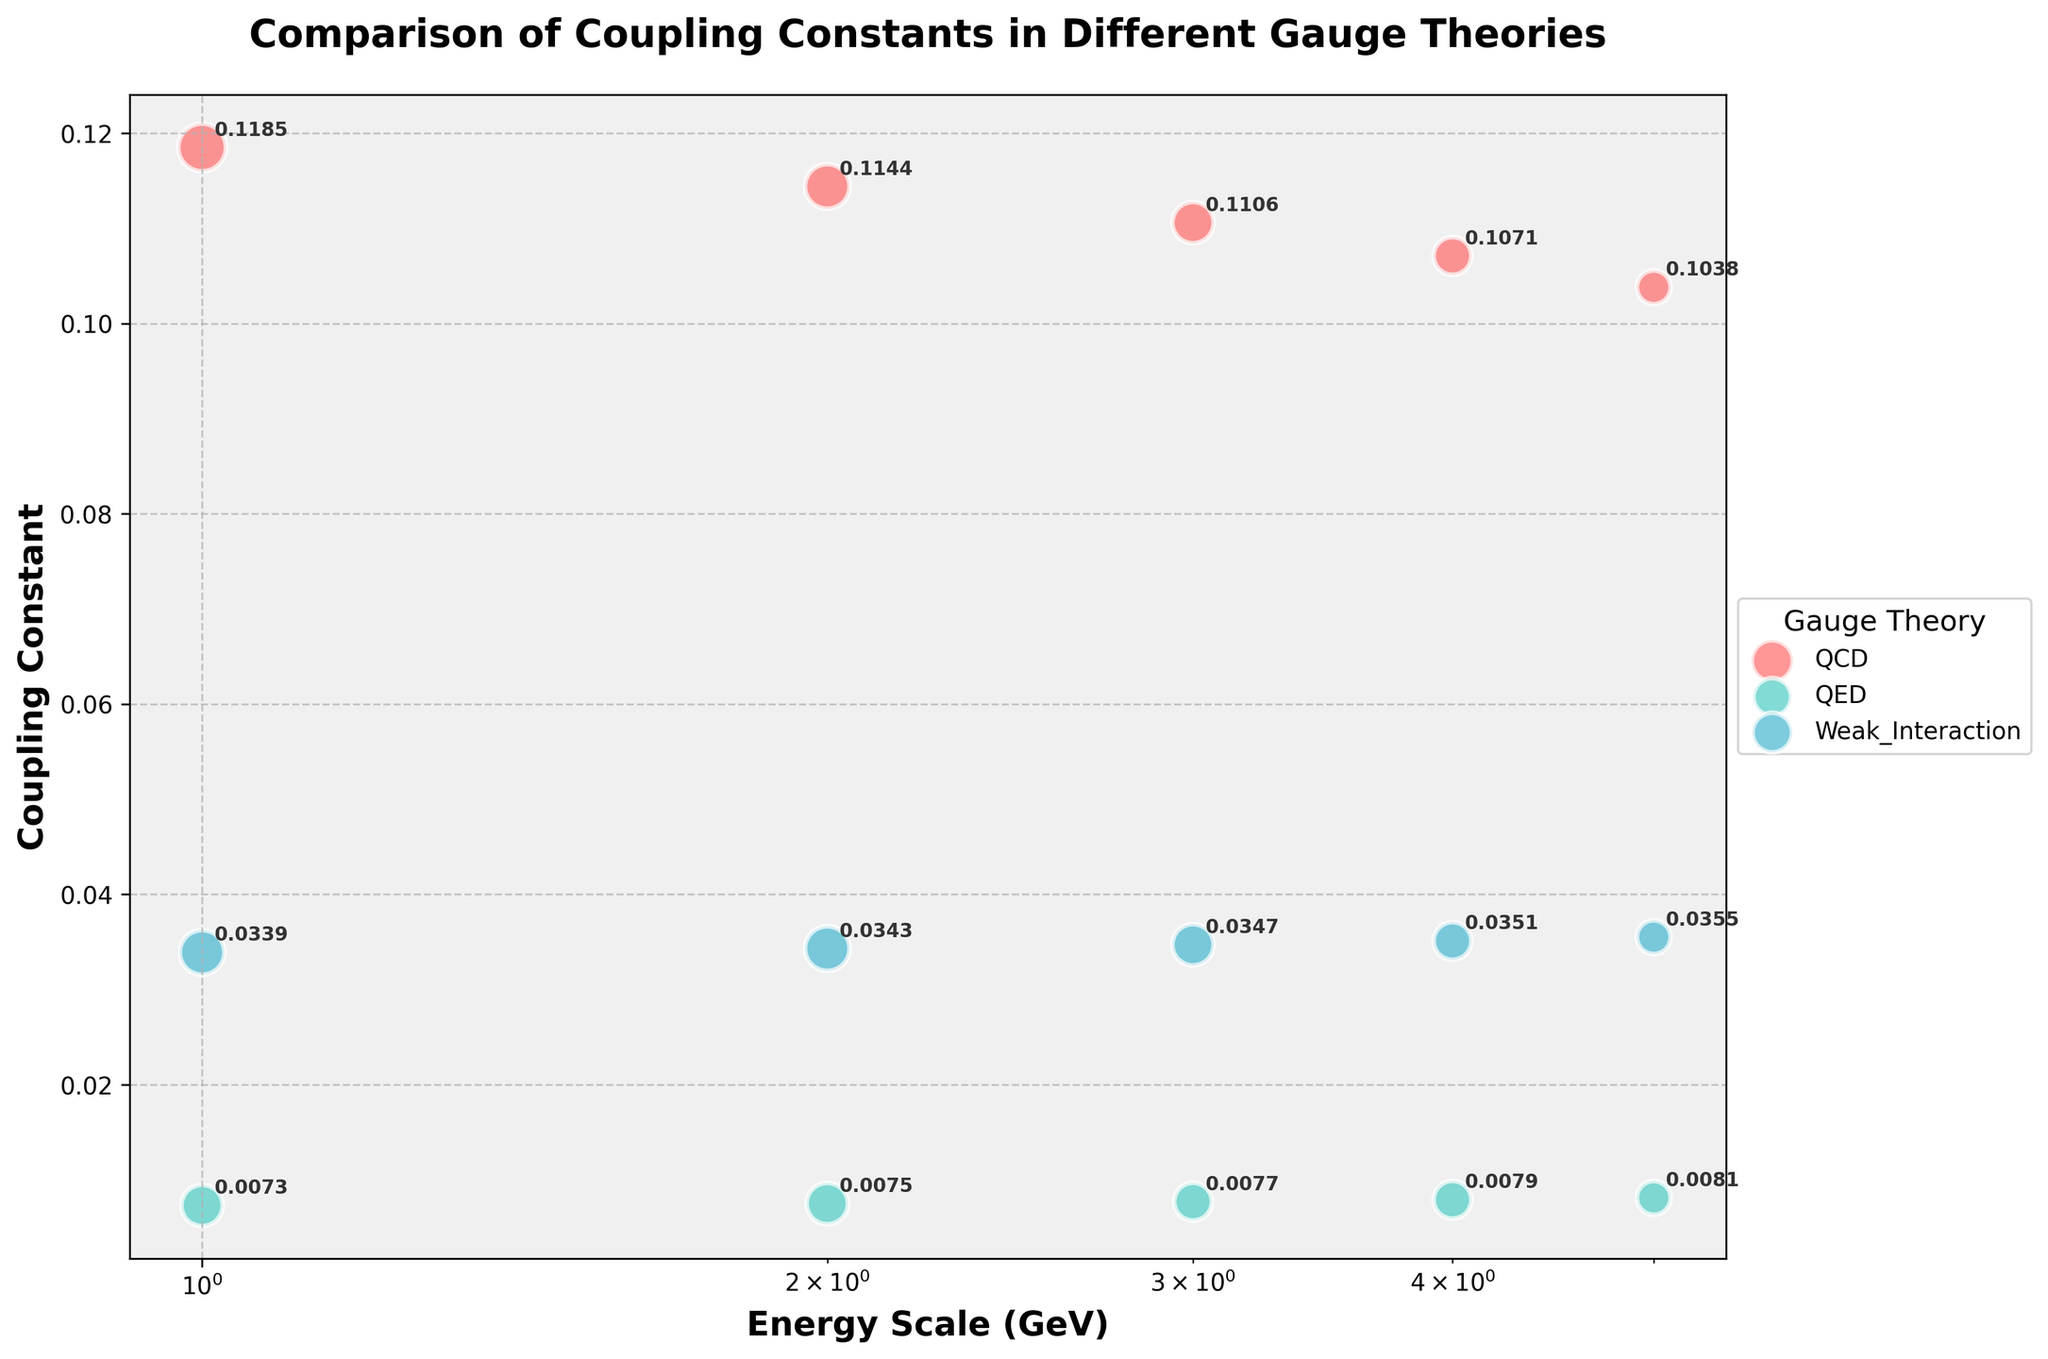What does the figure's title convey? The title of the figure is "Comparison of Coupling Constants in Different Gauge Theories". This indicates that the figure is comparing the values of coupling constants across various gauge theories over different energy scales.
Answer: Comparison of Coupling Constants in Different Gauge Theories How many different gauge theories are represented, and which ones are they? The figure shows three different gauge theories represented by different colors. These are QCD (Quantum Chromodynamics), QED (Quantum Electrodynamics), and Weak Interaction.
Answer: QCD, QED, Weak Interaction What pattern do you observe in the coupling constants of QCD as the energy scale increases? As the energy scale increases, the coupling constant of QCD decreases. This can be observed by looking at the downward trend in the orange bubble's positions on the y-axis as the x-axis values increase.
Answer: Decreases How does the theoretical importance vary between QCD and QED at an energy scale of 10 GeV? At an energy scale of 10 GeV, the theoretical importance for QCD is 8 and for QED is 6. This means that QCD has a higher theoretical importance than QED at this energy scale.
Answer: QCD: 8, QED: 6 Which gauge theory exhibits the smallest change in its coupling constant across the entire energy scale range? The QED gauge theory exhibits the smallest change in its coupling constant across the entire energy scale range. This can be seen from the fairly horizontal trend line of the teal bubbles representing QED.
Answer: QED At an energy scale of 1000 GeV, which gauge theory has the largest coupling constant? At an energy scale of 1000 GeV, the Weak Interaction gauge theory has the largest coupling constant, which is 0.0347.
Answer: Weak Interaction Compare the coupling constants of Weak Interaction and QCD at 100,000 GeV. Which one is larger and by how much? At 100,000 GeV, the coupling constant for Weak Interaction is 0.0355 and for QCD is 0.1038. The coupling constant for QCD is larger by 0.1038 - 0.0355, which is 0.0683.
Answer: QCD by 0.0683 What is the average theoretical importance for QED across all energy scales? The theoretical importance for QED across all energy scales is given as 6, 6, 5, 5, and 4. Adding these gives 6 + 6 + 5 + 5 + 4 = 26. Dividing by 5 (the number of scales) gives an average theoretical importance of 5.2.
Answer: 5.2 By looking at the annotated values, identify the coupling constant of QCD at 10 GeV and its theoretical importance. At 10 GeV, the coupling constant of QCD is annotated as 0.1185 and its theoretical importance is 8, as indicated by the size of the bubble.
Answer: 0.1185, 8 Assuming the bubble size represents theoretical importance, how does the relative importance of Weak Interaction change from 10 GeV to 100,000 GeV? The theoretical importance of Weak Interaction decreases from 7 at 10 GeV to 4 at 100,000 GeV, indicating a decline in its relative importance as the energy scale increases.
Answer: Decreases 